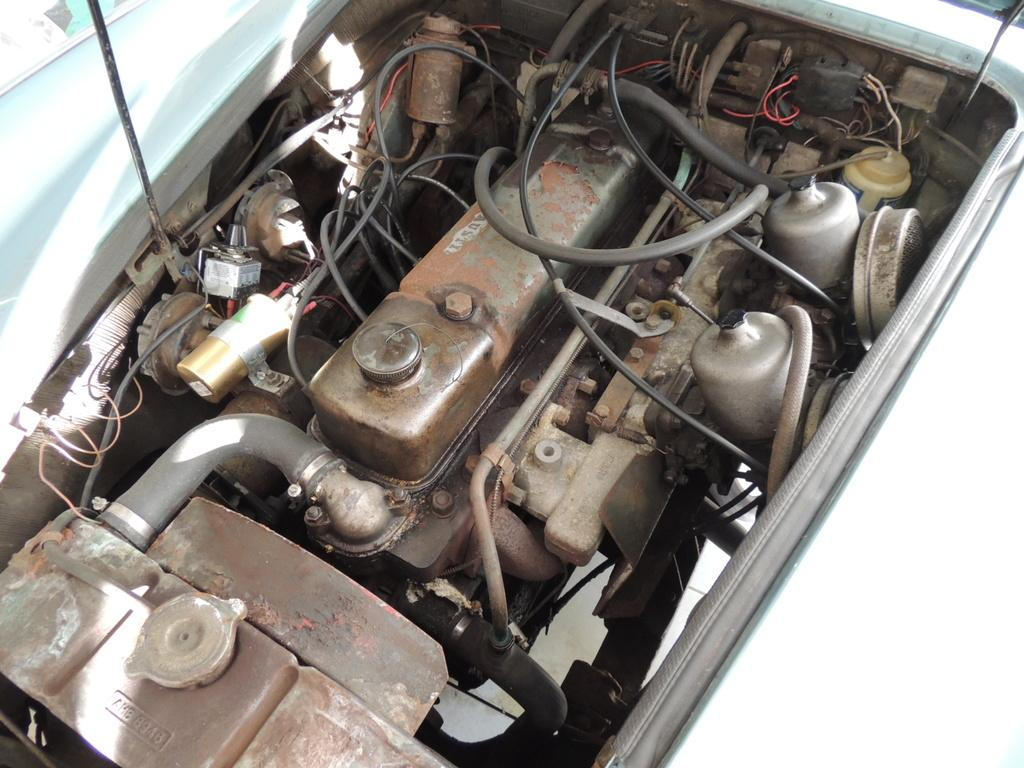What is the main subject of the image? The main subject of the image is a vehicle's engine. Can you describe the engine in more detail? Unfortunately, the provided facts do not offer any additional details about the engine. What type of protest is taking place near the vehicle's engine in the image? There is no protest present in the image; it only features a vehicle's engine. What time of day is depicted in the image? The provided facts do not offer any information about the time of day in the image. 